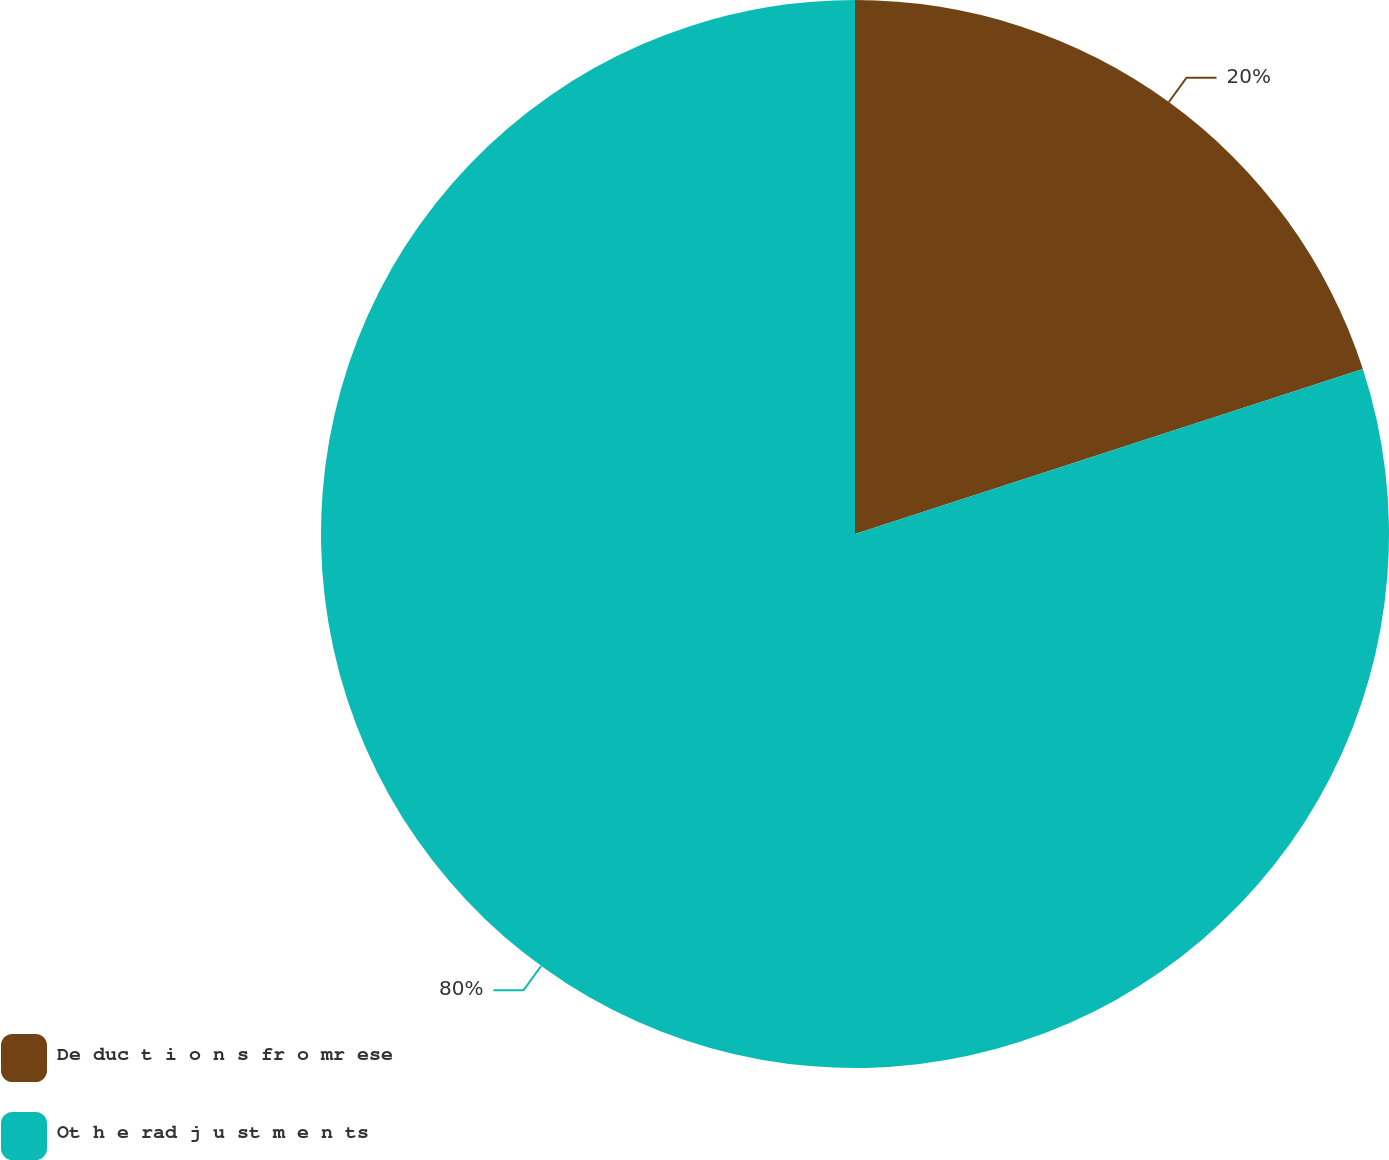Convert chart. <chart><loc_0><loc_0><loc_500><loc_500><pie_chart><fcel>De duc t i o n s fr o mr ese<fcel>Ot h e rad j u st m e n ts<nl><fcel>20.0%<fcel>80.0%<nl></chart> 